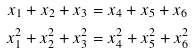Convert formula to latex. <formula><loc_0><loc_0><loc_500><loc_500>x _ { 1 } + x _ { 2 } + x _ { 3 } & = x _ { 4 } + x _ { 5 } + x _ { 6 } \\ x _ { 1 } ^ { 2 } + x _ { 2 } ^ { 2 } + x _ { 3 } ^ { 2 } & = x _ { 4 } ^ { 2 } + x _ { 5 } ^ { 2 } + x _ { 6 } ^ { 2 }</formula> 